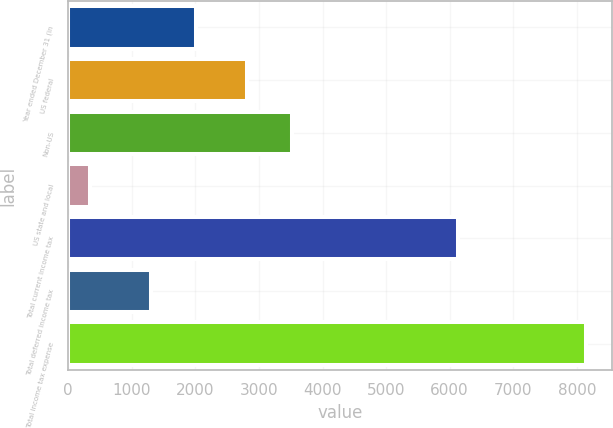Convert chart to OTSL. <chart><loc_0><loc_0><loc_500><loc_500><bar_chart><fcel>Year ended December 31 (in<fcel>US federal<fcel>Non-US<fcel>US state and local<fcel>Total current income tax<fcel>Total deferred income tax<fcel>Total income tax expense<nl><fcel>2016.7<fcel>2805<fcel>3514.7<fcel>343<fcel>6133<fcel>1307<fcel>8149.7<nl></chart> 